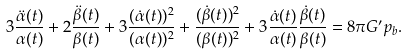Convert formula to latex. <formula><loc_0><loc_0><loc_500><loc_500>3 \frac { \ddot { \alpha } ( t ) } { \alpha ( t ) } + 2 \frac { \ddot { \beta } ( t ) } { \beta ( t ) } + 3 \frac { ( \dot { \alpha } ( t ) ) ^ { 2 } } { ( \alpha ( t ) ) ^ { 2 } } + \frac { ( \dot { \beta } ( t ) ) ^ { 2 } } { ( \beta ( t ) ) ^ { 2 } } + 3 { \frac { \dot { \alpha } ( t ) } { \alpha ( t ) } } { \frac { \dot { \beta } ( t ) } { \beta ( t ) } } = 8 { \pi } G ^ { \prime } { p _ { b } } .</formula> 